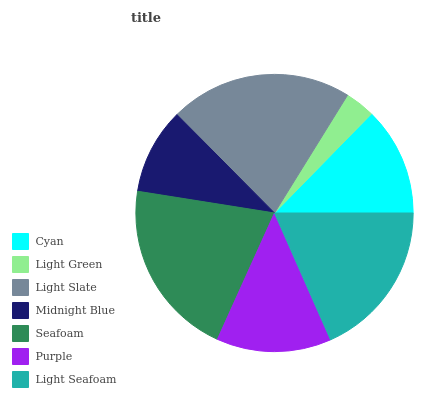Is Light Green the minimum?
Answer yes or no. Yes. Is Light Slate the maximum?
Answer yes or no. Yes. Is Light Slate the minimum?
Answer yes or no. No. Is Light Green the maximum?
Answer yes or no. No. Is Light Slate greater than Light Green?
Answer yes or no. Yes. Is Light Green less than Light Slate?
Answer yes or no. Yes. Is Light Green greater than Light Slate?
Answer yes or no. No. Is Light Slate less than Light Green?
Answer yes or no. No. Is Purple the high median?
Answer yes or no. Yes. Is Purple the low median?
Answer yes or no. Yes. Is Light Slate the high median?
Answer yes or no. No. Is Light Seafoam the low median?
Answer yes or no. No. 